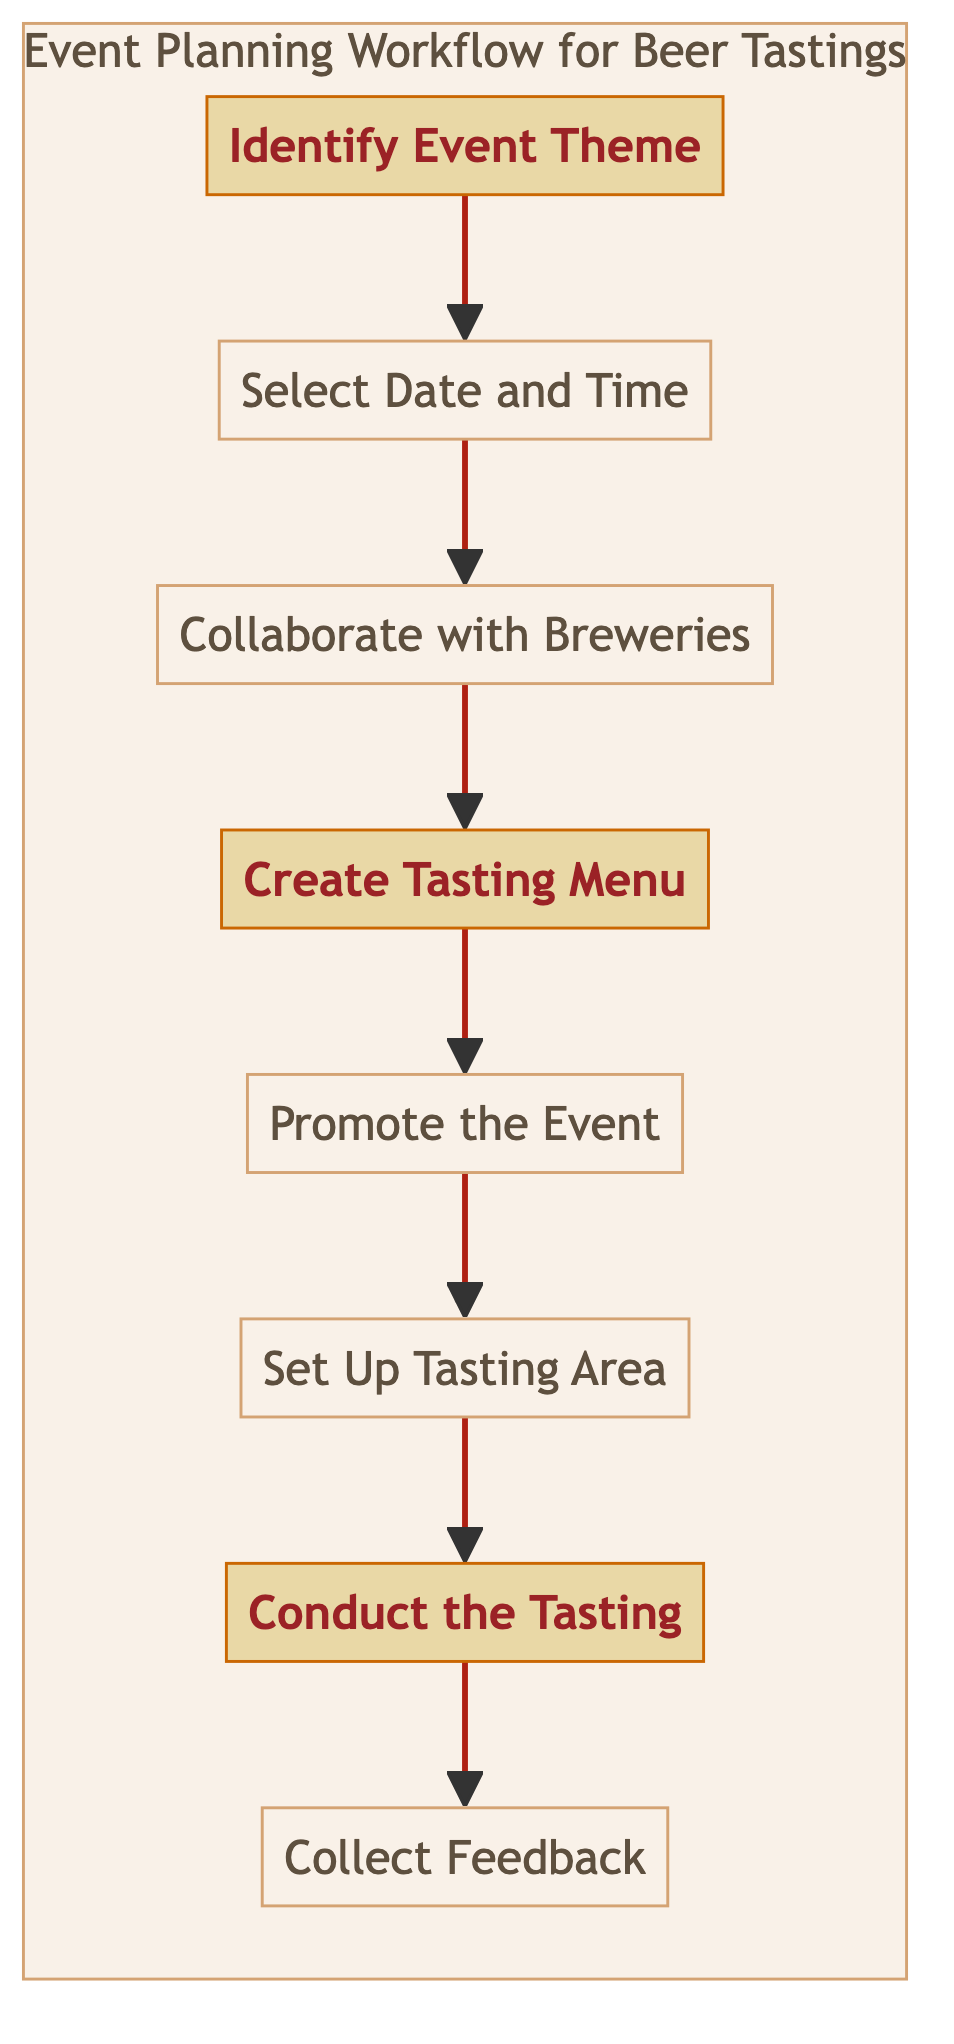What is the first step in the event planning workflow? The first step listed in the diagram is "Identify Event Theme." This is the initial action noted at the top of the flowchart, indicating where to start the planning process.
Answer: Identify Event Theme How many steps are in the workflow? By counting the nodes in the diagram, there are a total of eight steps outlined in the workflow, from "Identify Event Theme" to "Collect Feedback."
Answer: Eight steps What is the last step in the workflow? The last step detailed in the flowchart is "Collect Feedback." This step is positioned at the end of the sequence, concluding the event planning process.
Answer: Collect Feedback Which step comes directly after "Create Tasting Menu"? Following the "Create Tasting Menu" step, the next step indicated in the diagram is "Promote the Event." This is the immediate progression in the workflow.
Answer: Promote the Event What is highlighted in the diagram? The steps "Identify Event Theme," "Create Tasting Menu," and "Conduct the Tasting" are highlighted in the flowchart, indicating their significance within the process.
Answer: Identify Event Theme, Create Tasting Menu, Conduct the Tasting What does the workflow suggest should be done after selecting the date and time? After selecting the date and time, the diagram indicates the next action is to "Collaborate with Breweries." This process follows logically in the event planning sequence.
Answer: Collaborate with Breweries How are the steps in the workflow connected? The steps in the diagram are connected by arrows, showing a direct progression from one step to the next without any branches or loops, indicating a linear flow.
Answer: Linear flow What is the purpose of the "Set Up Tasting Area" step? The "Set Up Tasting Area" step is about arranging seating and tables to create an environment conducive to interaction and comfort for the participants, as stated in the description.
Answer: Arrange seating and tables for interaction and comfort 